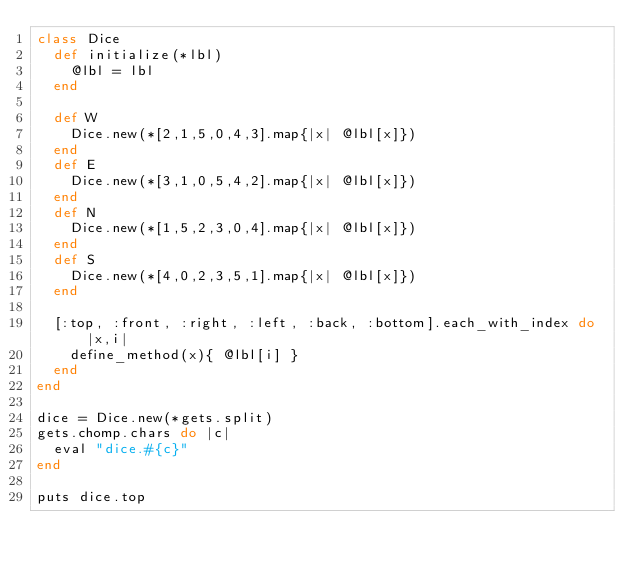<code> <loc_0><loc_0><loc_500><loc_500><_Ruby_>class Dice
  def initialize(*lbl)
    @lbl = lbl
  end

  def W
    Dice.new(*[2,1,5,0,4,3].map{|x| @lbl[x]})
  end
  def E
    Dice.new(*[3,1,0,5,4,2].map{|x| @lbl[x]})
  end
  def N
    Dice.new(*[1,5,2,3,0,4].map{|x| @lbl[x]})
  end
  def S
    Dice.new(*[4,0,2,3,5,1].map{|x| @lbl[x]})
  end

  [:top, :front, :right, :left, :back, :bottom].each_with_index do |x,i|
    define_method(x){ @lbl[i] }
  end
end

dice = Dice.new(*gets.split)
gets.chomp.chars do |c|
  eval "dice.#{c}"
end

puts dice.top</code> 